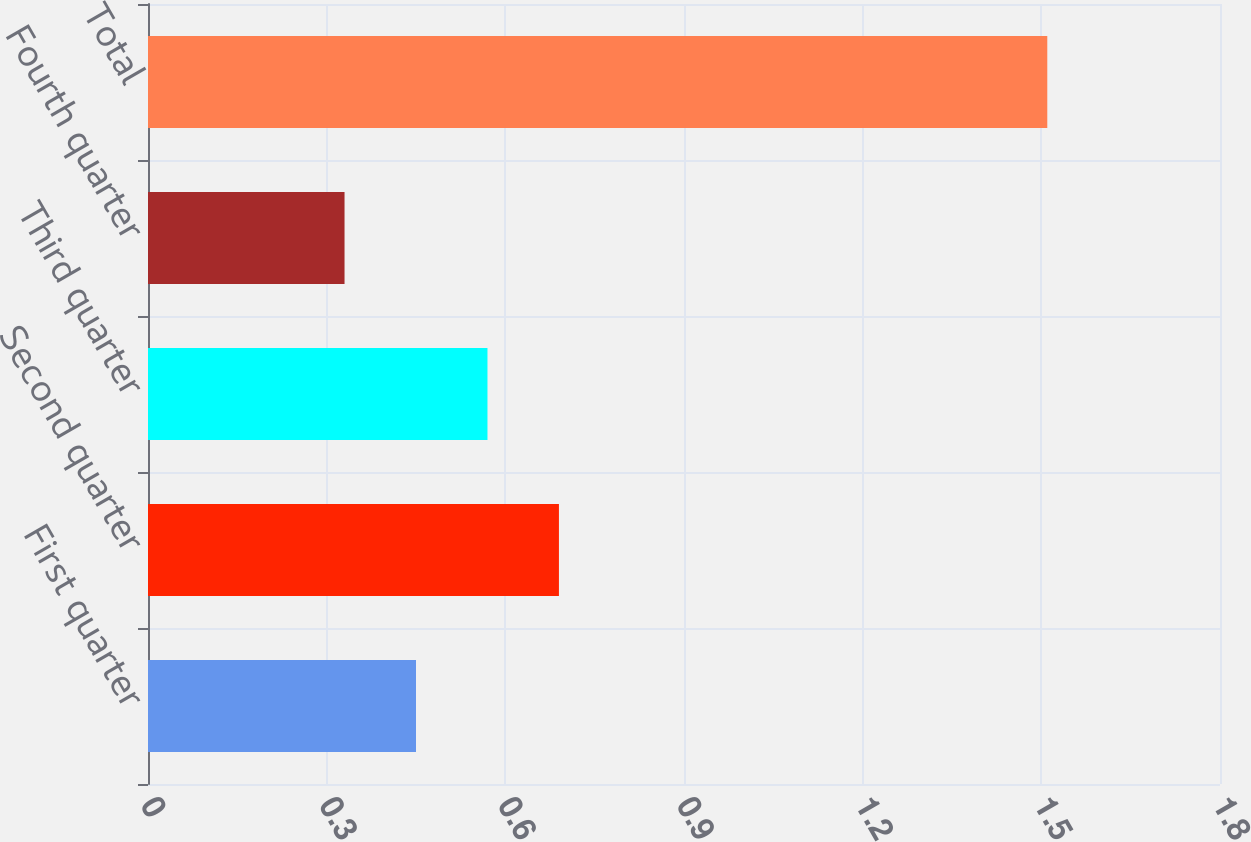Convert chart to OTSL. <chart><loc_0><loc_0><loc_500><loc_500><bar_chart><fcel>First quarter<fcel>Second quarter<fcel>Third quarter<fcel>Fourth quarter<fcel>Total<nl><fcel>0.45<fcel>0.69<fcel>0.57<fcel>0.33<fcel>1.51<nl></chart> 